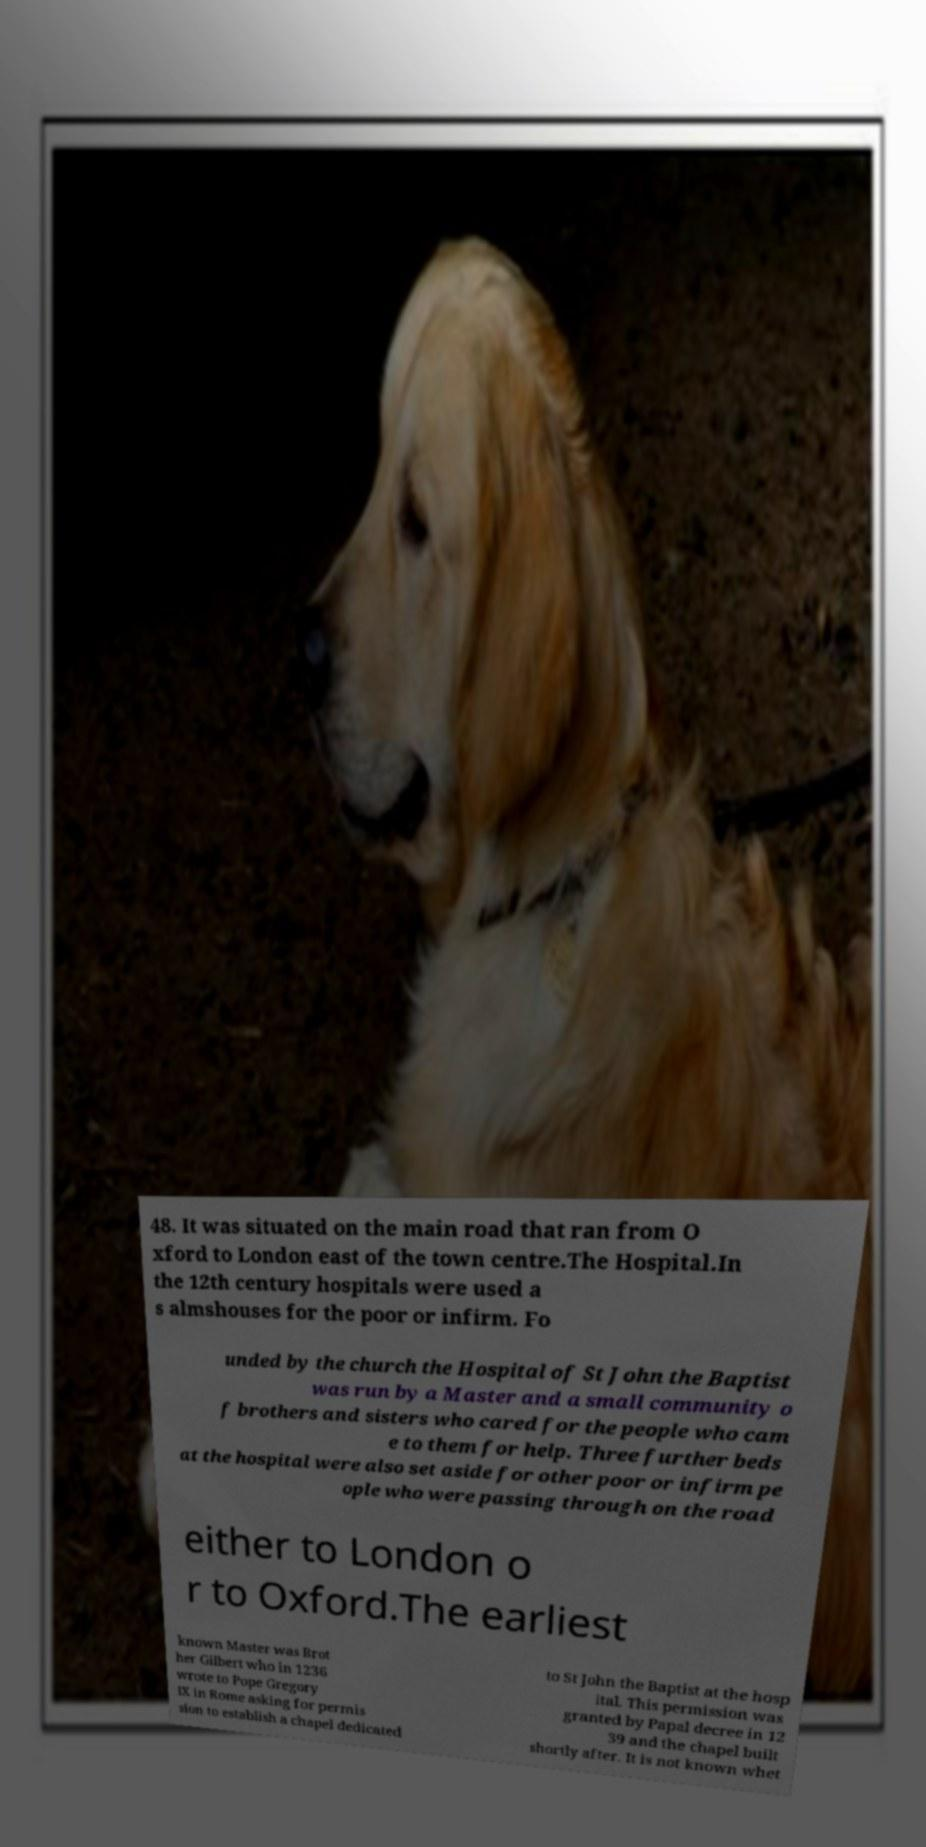Please identify and transcribe the text found in this image. 48. It was situated on the main road that ran from O xford to London east of the town centre.The Hospital.In the 12th century hospitals were used a s almshouses for the poor or infirm. Fo unded by the church the Hospital of St John the Baptist was run by a Master and a small community o f brothers and sisters who cared for the people who cam e to them for help. Three further beds at the hospital were also set aside for other poor or infirm pe ople who were passing through on the road either to London o r to Oxford.The earliest known Master was Brot her Gilbert who in 1236 wrote to Pope Gregory IX in Rome asking for permis sion to establish a chapel dedicated to St John the Baptist at the hosp ital. This permission was granted by Papal decree in 12 39 and the chapel built shortly after. It is not known whet 